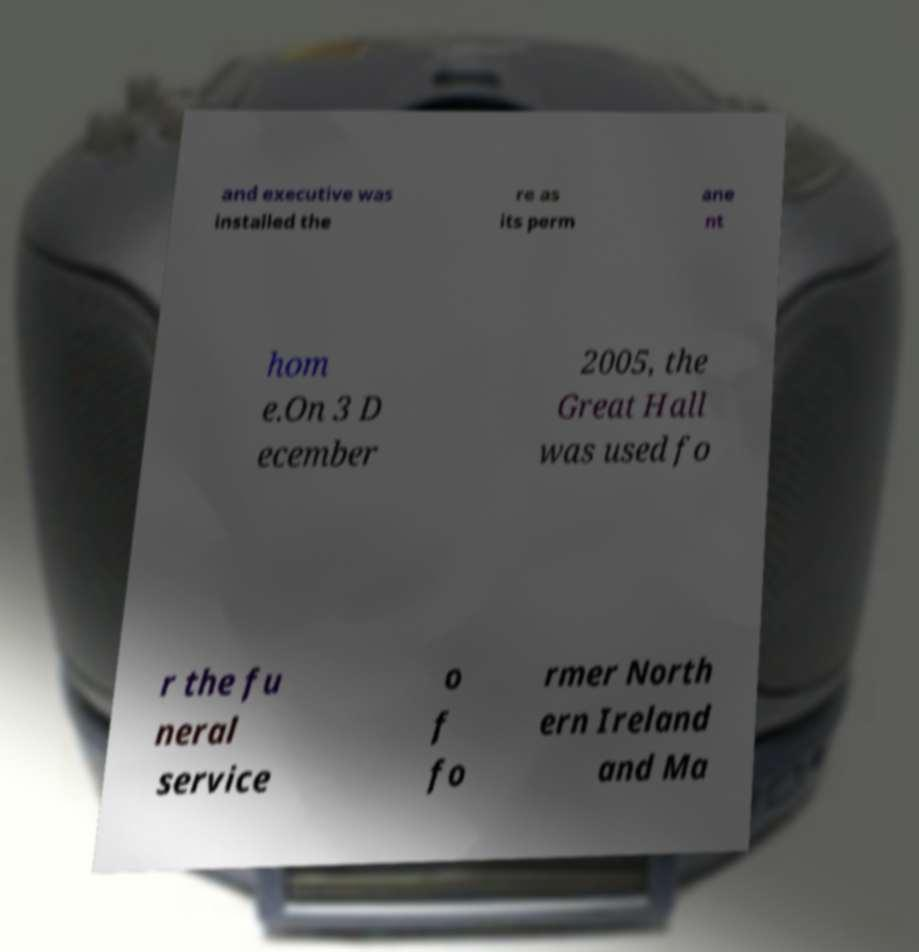What messages or text are displayed in this image? I need them in a readable, typed format. and executive was installed the re as its perm ane nt hom e.On 3 D ecember 2005, the Great Hall was used fo r the fu neral service o f fo rmer North ern Ireland and Ma 